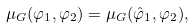Convert formula to latex. <formula><loc_0><loc_0><loc_500><loc_500>\mu _ { G } ( \varphi _ { 1 } , \varphi _ { 2 } ) = \mu _ { G } ( \hat { \varphi } _ { 1 } , \varphi _ { 2 } ) ,</formula> 